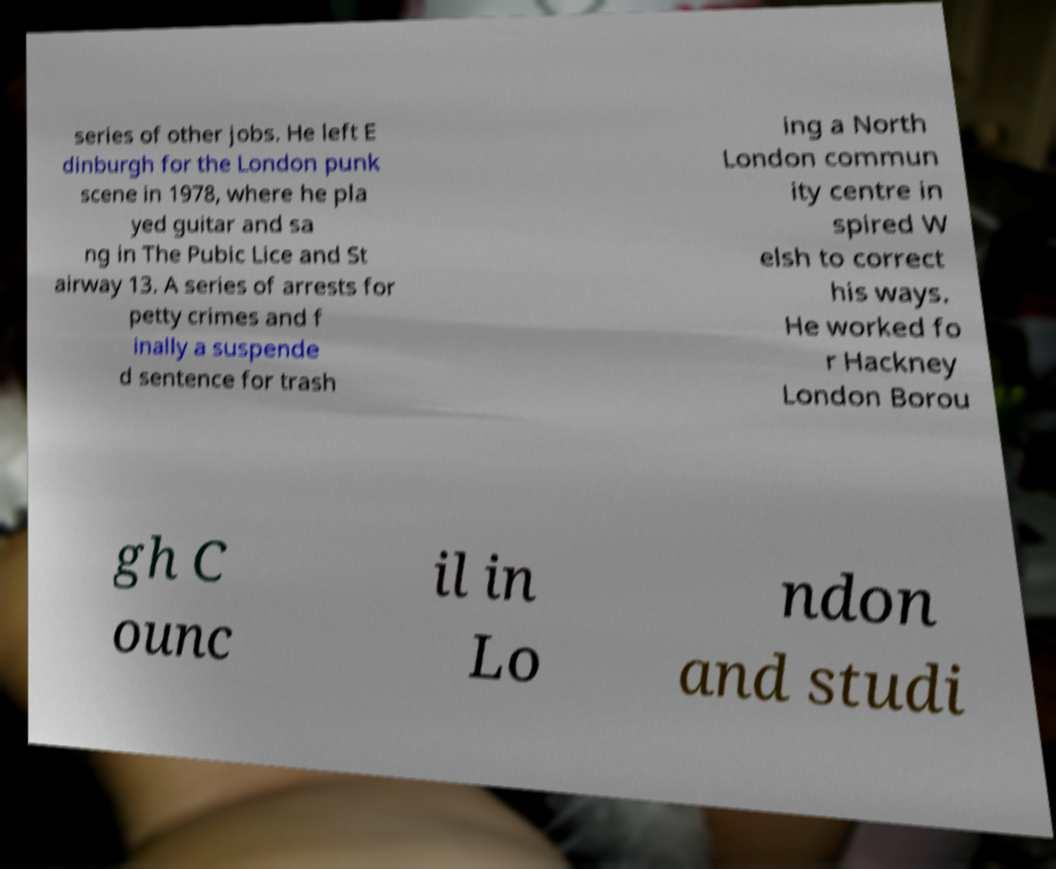What messages or text are displayed in this image? I need them in a readable, typed format. series of other jobs. He left E dinburgh for the London punk scene in 1978, where he pla yed guitar and sa ng in The Pubic Lice and St airway 13. A series of arrests for petty crimes and f inally a suspende d sentence for trash ing a North London commun ity centre in spired W elsh to correct his ways. He worked fo r Hackney London Borou gh C ounc il in Lo ndon and studi 